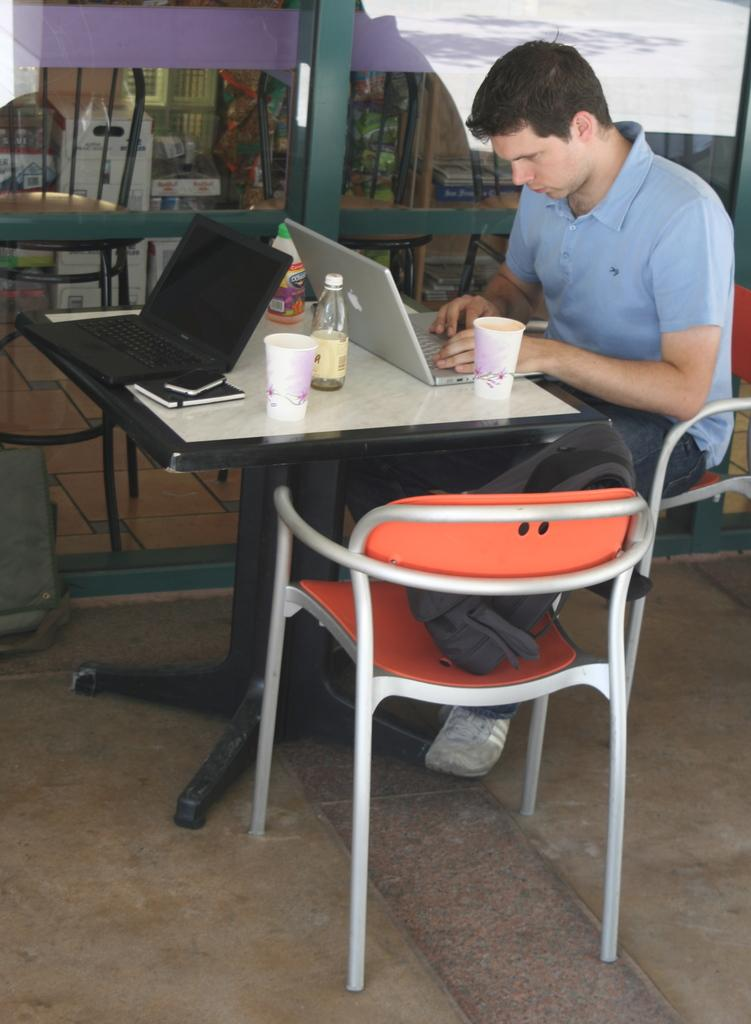What is the main subject of the picture? The main subject of the picture is a man. What is the man doing in the picture? The man is sitting on a chair and looking at a laptop. What objects are present on the table in the image? There is a cup, a bottle, and a phone on the table. How far away is the tree from the man in the image? There is no tree present in the image. 